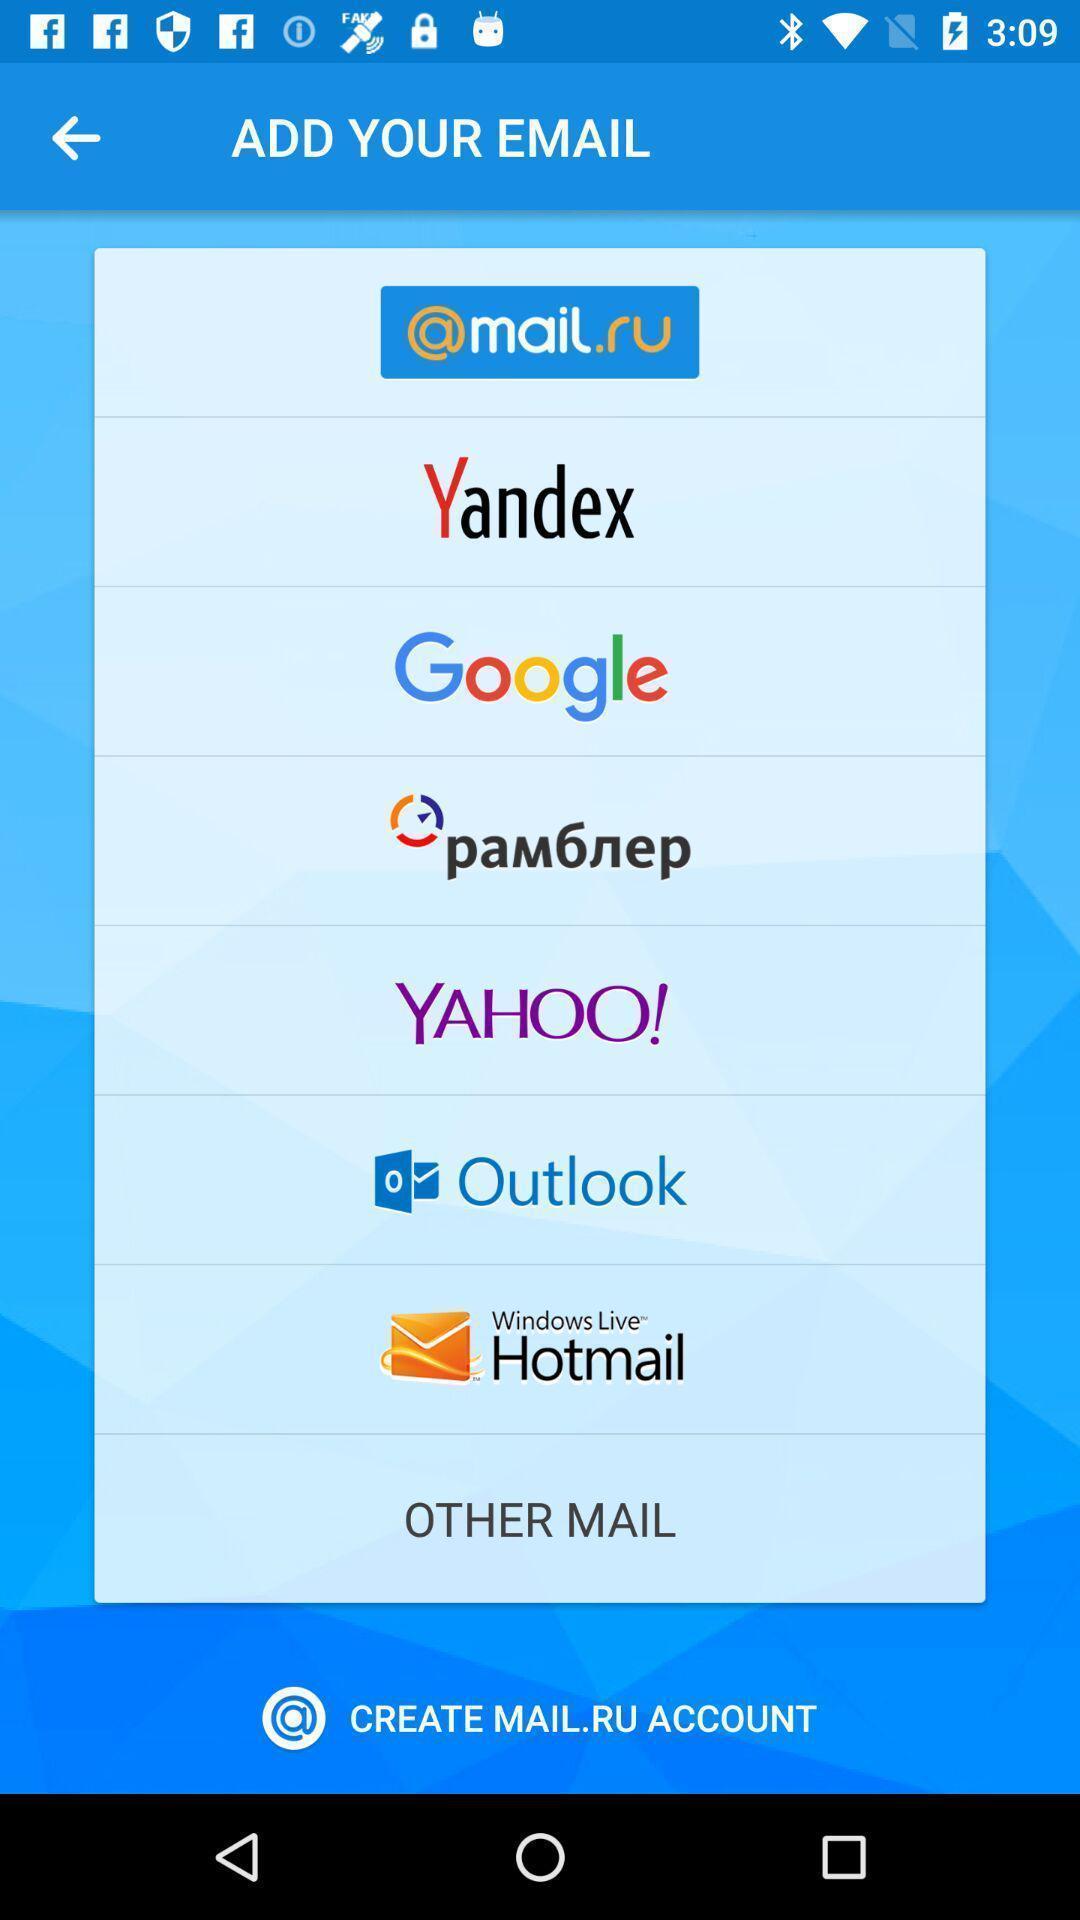Provide a detailed account of this screenshot. Page shows add your email in an service application. 